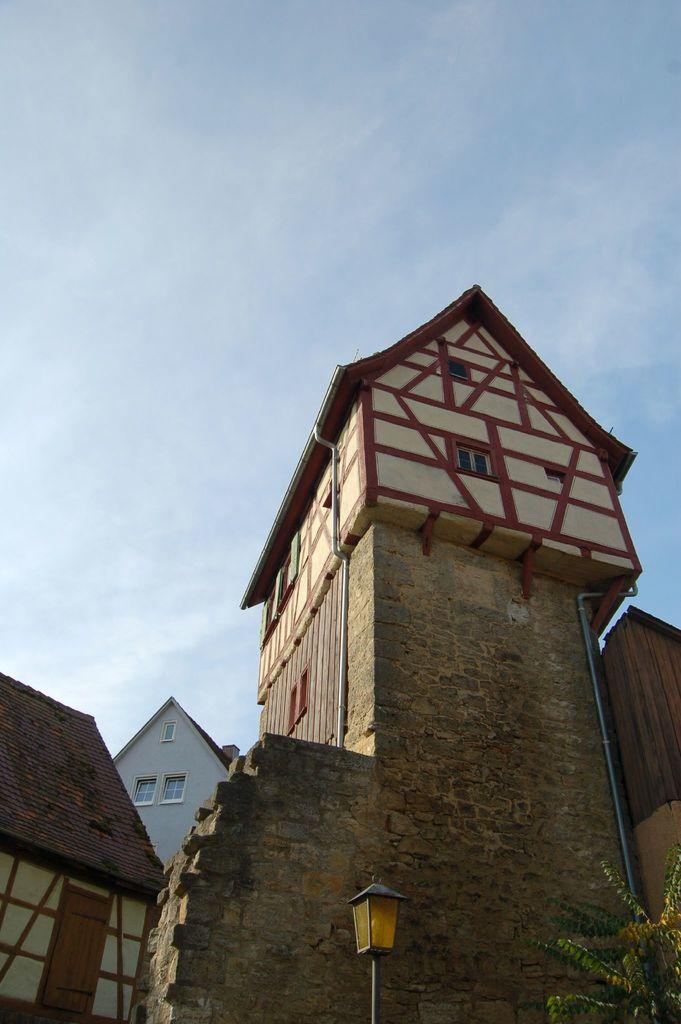What type of structures can be seen in the image? There are buildings in the image. What other elements are present in the image besides buildings? There are plants in the image. What part of the natural environment is visible in the image? The sky is visible in the image. How many cherries are hanging from the buildings in the image? There are no cherries present in the image; it features buildings and plants. What type of beast can be seen interacting with the plants in the image? There is no beast present in the image; only buildings, plants, and the sky are visible. 